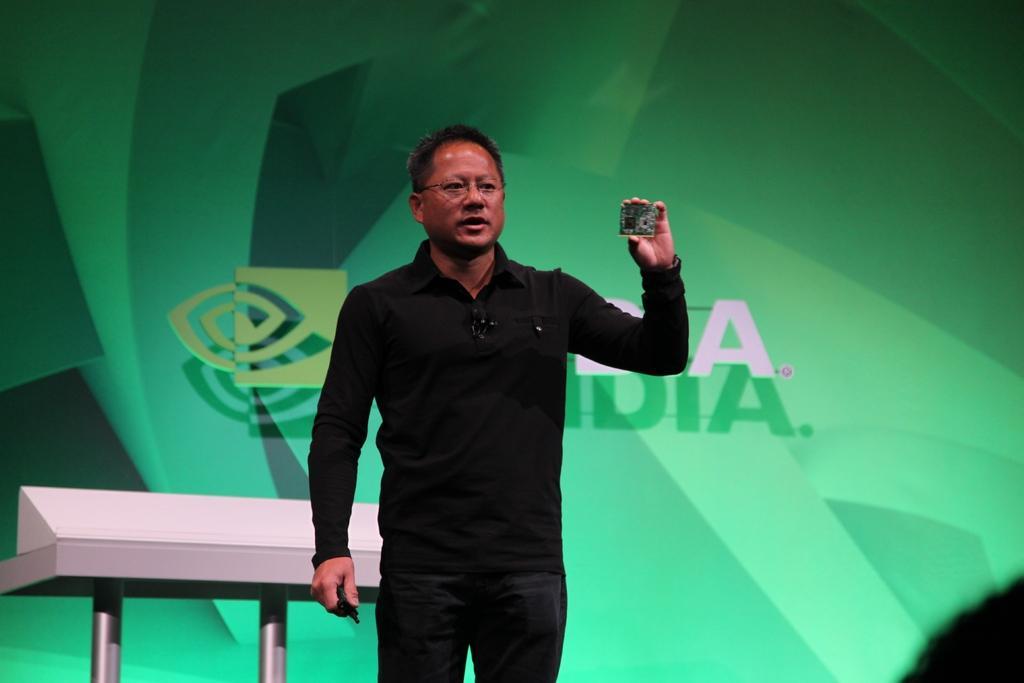Describe this image in one or two sentences. In this picture there is a man wearing black color t-shirt, standing in front and holding the motherboard chip in the hand. Behind there is a white table and green banner in the background. 